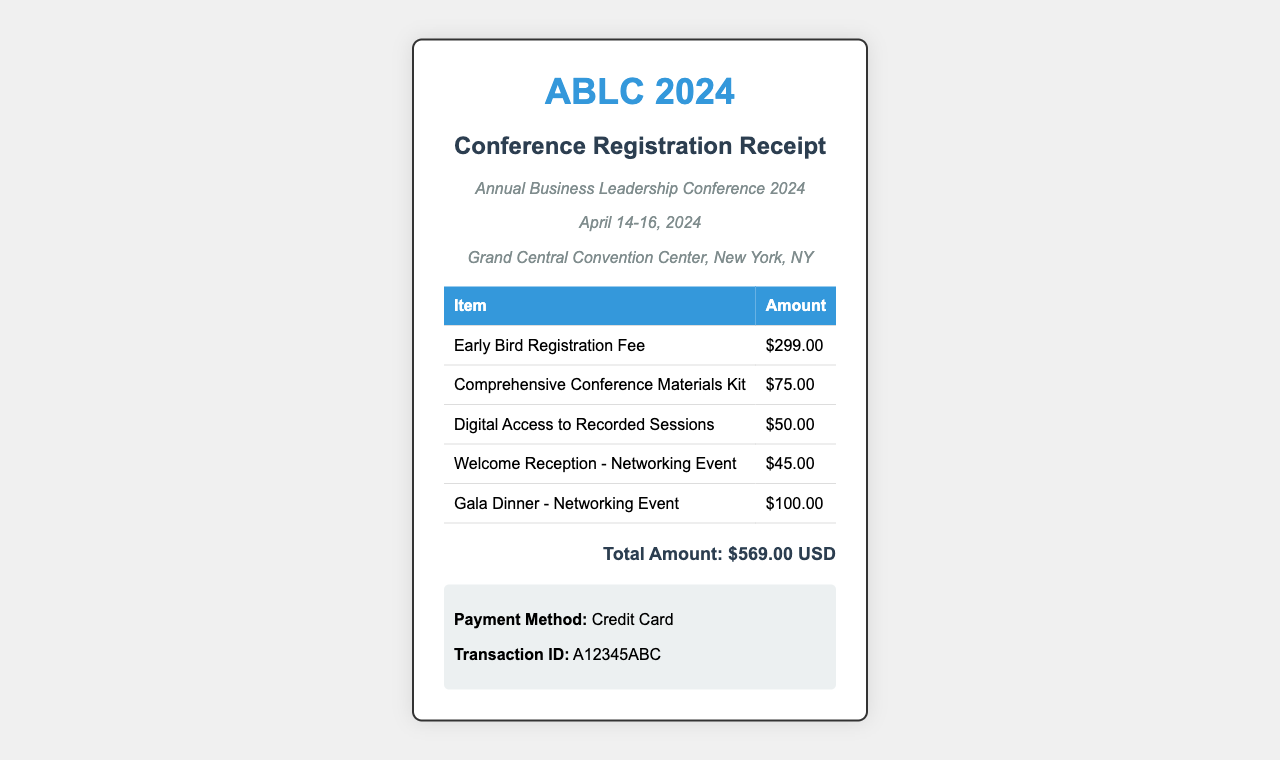What is the name of the conference? The conference is called the "Annual Business Leadership Conference 2024," which is stated in the document.
Answer: Annual Business Leadership Conference 2024 When is the conference taking place? The conference dates are mentioned in the document as April 14-16, 2024.
Answer: April 14-16, 2024 What is the total amount due for the registration? The total amount is explicitly stated at the bottom of the receipt as $569.00 USD.
Answer: $569.00 USD How much is the Early Bird Registration Fee? The fee for Early Bird Registration is listed in the table as $299.00.
Answer: $299.00 How much do the networking events (Welcome Reception and Gala Dinner) cost combined? The costs for the two networking events are $45.00 for Welcome Reception and $100.00 for Gala Dinner, totaling $145.00 when added.
Answer: $145.00 What is the payment method used? The method of payment is indicated in the payment information section as Credit Card.
Answer: Credit Card What item has the lowest fee on the receipt? The item with the lowest fee is the Welcome Reception - Networking Event, which costs $45.00.
Answer: $45.00 What is included in the Comprehensive Conference Materials Kit? The document lists the Comprehensive Conference Materials Kit as one of the items, but does not specify its contents; however, it has a fee of $75.00.
Answer: $75.00 How many days does the conference last? The conference lasts for three days, from April 14 to April 16.
Answer: 3 days 